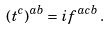Convert formula to latex. <formula><loc_0><loc_0><loc_500><loc_500>( t ^ { c } ) ^ { a b } = i f ^ { a c b } \, .</formula> 